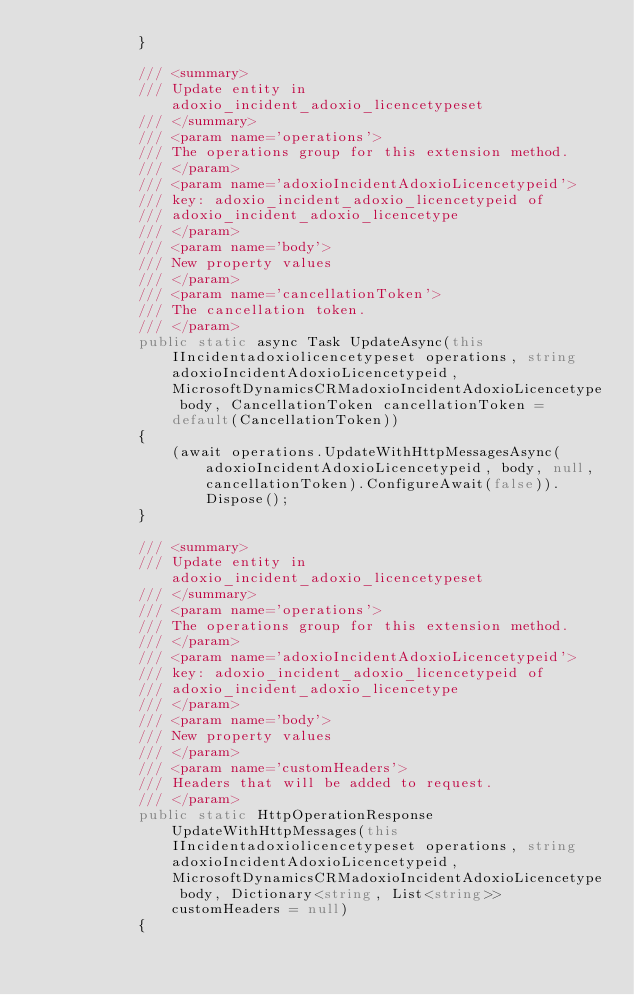<code> <loc_0><loc_0><loc_500><loc_500><_C#_>            }

            /// <summary>
            /// Update entity in adoxio_incident_adoxio_licencetypeset
            /// </summary>
            /// <param name='operations'>
            /// The operations group for this extension method.
            /// </param>
            /// <param name='adoxioIncidentAdoxioLicencetypeid'>
            /// key: adoxio_incident_adoxio_licencetypeid of
            /// adoxio_incident_adoxio_licencetype
            /// </param>
            /// <param name='body'>
            /// New property values
            /// </param>
            /// <param name='cancellationToken'>
            /// The cancellation token.
            /// </param>
            public static async Task UpdateAsync(this IIncidentadoxiolicencetypeset operations, string adoxioIncidentAdoxioLicencetypeid, MicrosoftDynamicsCRMadoxioIncidentAdoxioLicencetype body, CancellationToken cancellationToken = default(CancellationToken))
            {
                (await operations.UpdateWithHttpMessagesAsync(adoxioIncidentAdoxioLicencetypeid, body, null, cancellationToken).ConfigureAwait(false)).Dispose();
            }

            /// <summary>
            /// Update entity in adoxio_incident_adoxio_licencetypeset
            /// </summary>
            /// <param name='operations'>
            /// The operations group for this extension method.
            /// </param>
            /// <param name='adoxioIncidentAdoxioLicencetypeid'>
            /// key: adoxio_incident_adoxio_licencetypeid of
            /// adoxio_incident_adoxio_licencetype
            /// </param>
            /// <param name='body'>
            /// New property values
            /// </param>
            /// <param name='customHeaders'>
            /// Headers that will be added to request.
            /// </param>
            public static HttpOperationResponse UpdateWithHttpMessages(this IIncidentadoxiolicencetypeset operations, string adoxioIncidentAdoxioLicencetypeid, MicrosoftDynamicsCRMadoxioIncidentAdoxioLicencetype body, Dictionary<string, List<string>> customHeaders = null)
            {</code> 